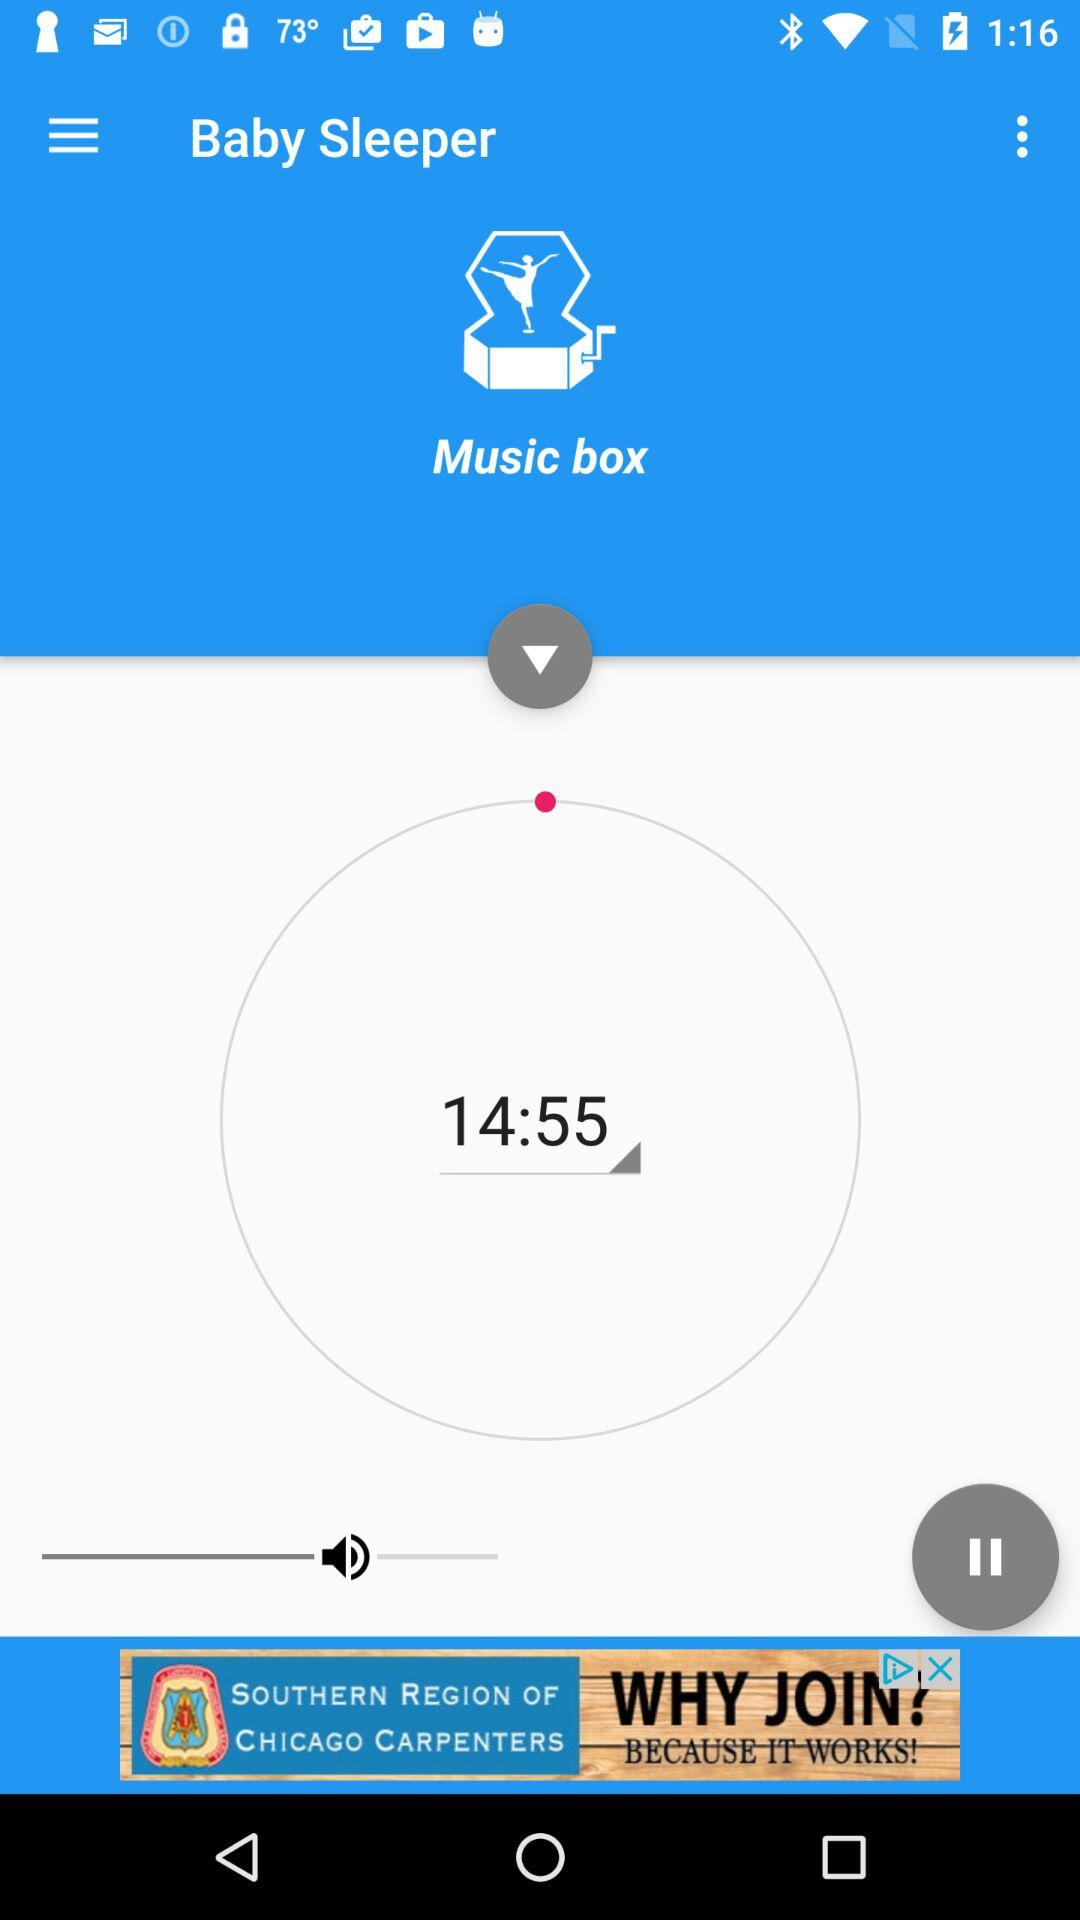What is the application name? The application name is "Baby Sleeper". 